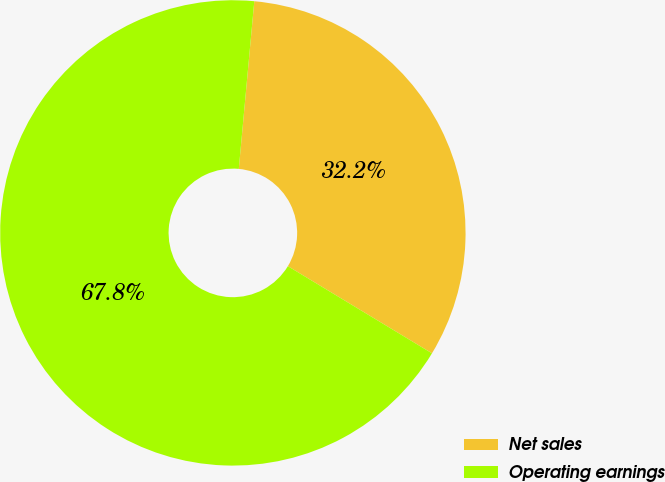<chart> <loc_0><loc_0><loc_500><loc_500><pie_chart><fcel>Net sales<fcel>Operating earnings<nl><fcel>32.19%<fcel>67.81%<nl></chart> 